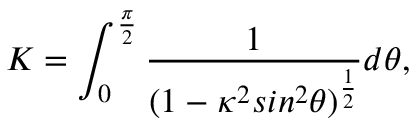Convert formula to latex. <formula><loc_0><loc_0><loc_500><loc_500>K = \int _ { 0 } ^ { \frac { \pi } { 2 } } \frac { 1 } { ( 1 - \kappa ^ { 2 } \sin ^ { 2 } \theta ) ^ { \frac { 1 } { 2 } } } d \theta ,</formula> 